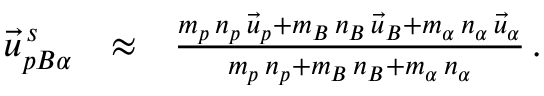Convert formula to latex. <formula><loc_0><loc_0><loc_500><loc_500>\begin{array} { r l r } { \vec { u } _ { p B \alpha } ^ { \, s } } & { \approx } & { \frac { m _ { p } \, n _ { p } \, \vec { u } _ { p } + m _ { B } \, n _ { B } \, \vec { u } _ { B } + m _ { \alpha } \, n _ { \alpha } \, \vec { u } _ { \alpha } } { m _ { p } \, n _ { p } + m _ { B } \, n _ { B } + m _ { \alpha } \, n _ { \alpha } } \, . } \end{array}</formula> 